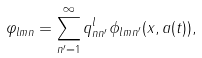<formula> <loc_0><loc_0><loc_500><loc_500>\varphi _ { l m n } = \sum _ { n ^ { \prime } = 1 } ^ { \infty } q _ { n n ^ { \prime } } ^ { l } \phi _ { l m n ^ { \prime } } ( x , a ( t ) ) ,</formula> 